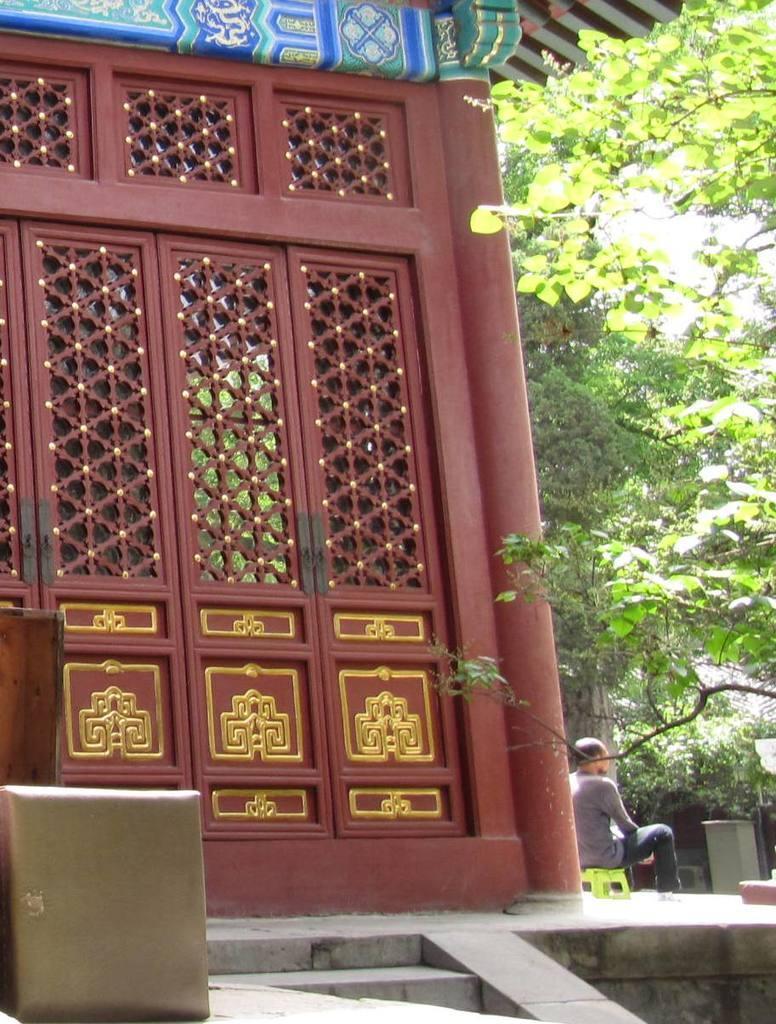Can you describe this image briefly? In this image we can see doors, some objects on the left side and there is a person sitting on the stool and there are few trees on the right side. 